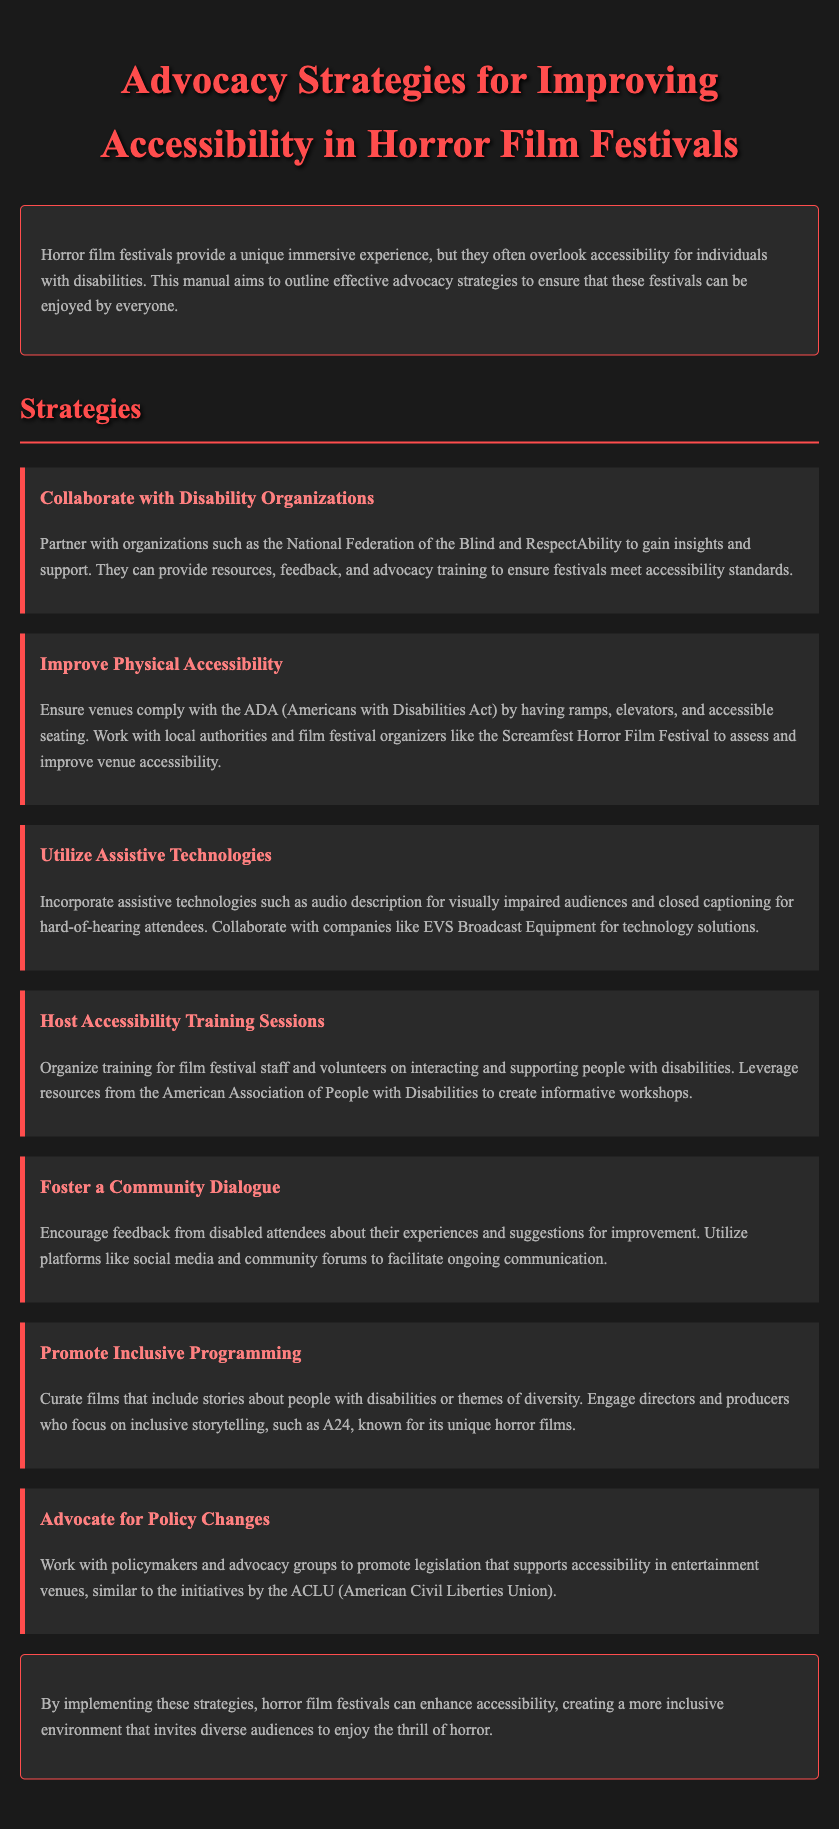what is the main purpose of the manual? The manual aims to outline effective advocacy strategies to ensure that horror film festivals can be enjoyed by everyone.
Answer: to ensure that horror film festivals can be enjoyed by everyone which organizations are suggested for collaboration? The document mentions partnering with the National Federation of the Blind and RespectAbility for insights and support.
Answer: National Federation of the Blind and RespectAbility what physical feature must venues comply with according to the ADA? The manual specifies having ramps, elevators, and accessible seating as compliance with the ADA.
Answer: ramps, elevators, and accessible seating what technology is recommended for visually impaired audiences? The document suggests incorporating audio description for visually impaired audiences.
Answer: audio description how many strategies are outlined in the document? There are a total of seven strategies outlined in the manual for improving accessibility.
Answer: seven who can provide training for film festival staff? The American Association of People with Disabilities is mentioned as a resource to create informative workshops.
Answer: American Association of People with Disabilities what type of films should be curated to promote inclusiveness? The manual suggests curating films that include stories about people with disabilities or themes of diversity.
Answer: stories about people with disabilities or themes of diversity which organization is mentioned in relation to advocating for policy changes? The document refers to the ACLU as an organization that supports advocacy for policy changes.
Answer: ACLU 